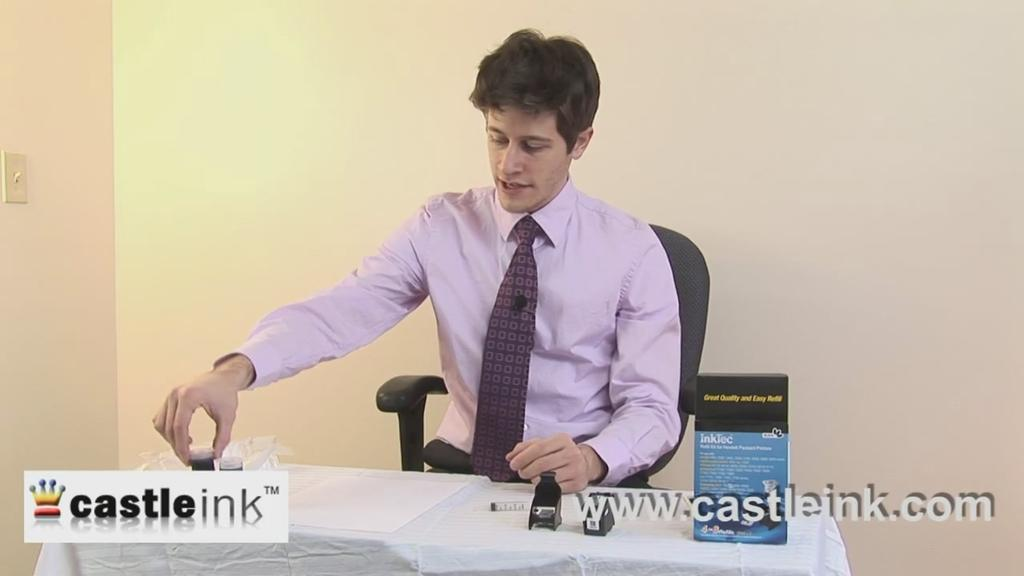Who is present in the image? There is a man in the image. What is the man doing in the image? The man is sitting in front of a table. What object can be seen on the table in the image? There is an ink bottle on the table. What type of science experiment is being conducted in the image? There is no science experiment or any indication of one being conducted in the image. 